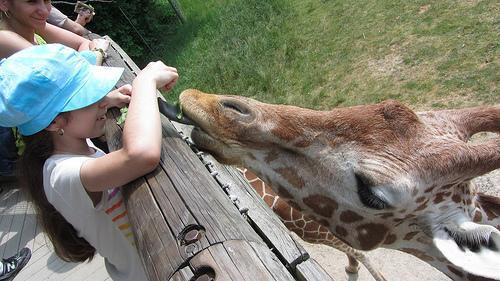How many giraffes are in this picture?
Give a very brief answer. 1. 